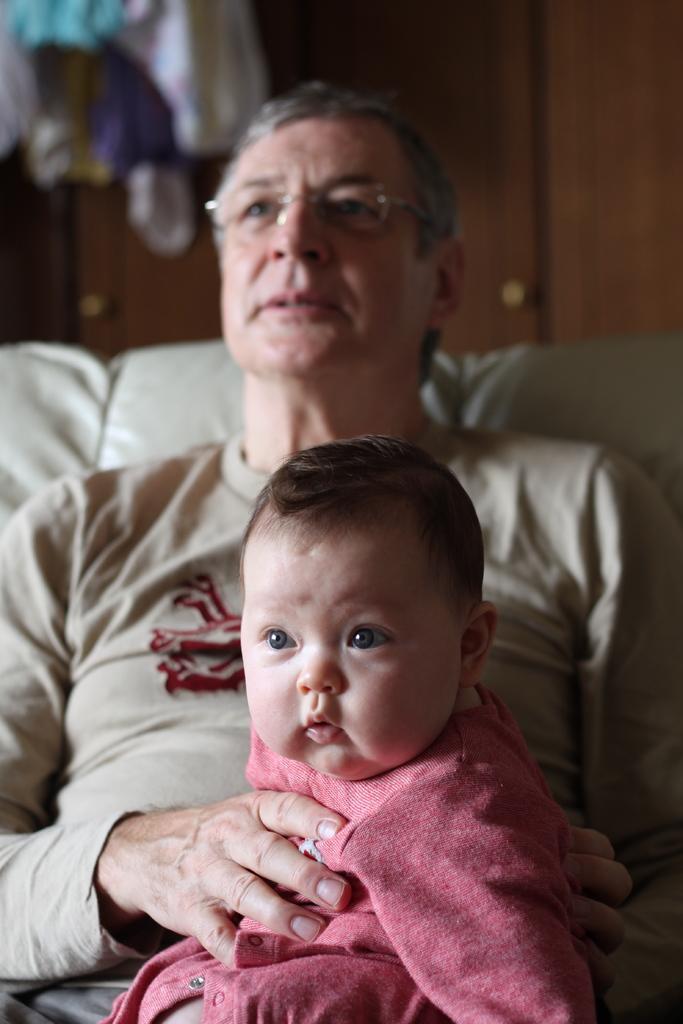Can you describe this image briefly? In this image, there are a few people. Among them, we can see a person wearing spectacles is sitting on the sofa. In the background, we can see some wood. We can also see an object in the top left corner. 